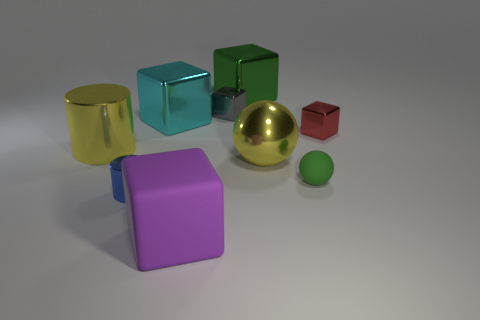Are there any patterns or consistency in the sizes of the objects? The objects show a variety of sizes with no apparent pattern; there are large objects like the gold sphere, medium-sized objects like the cubes, and smaller objects like the tiny green ball. 